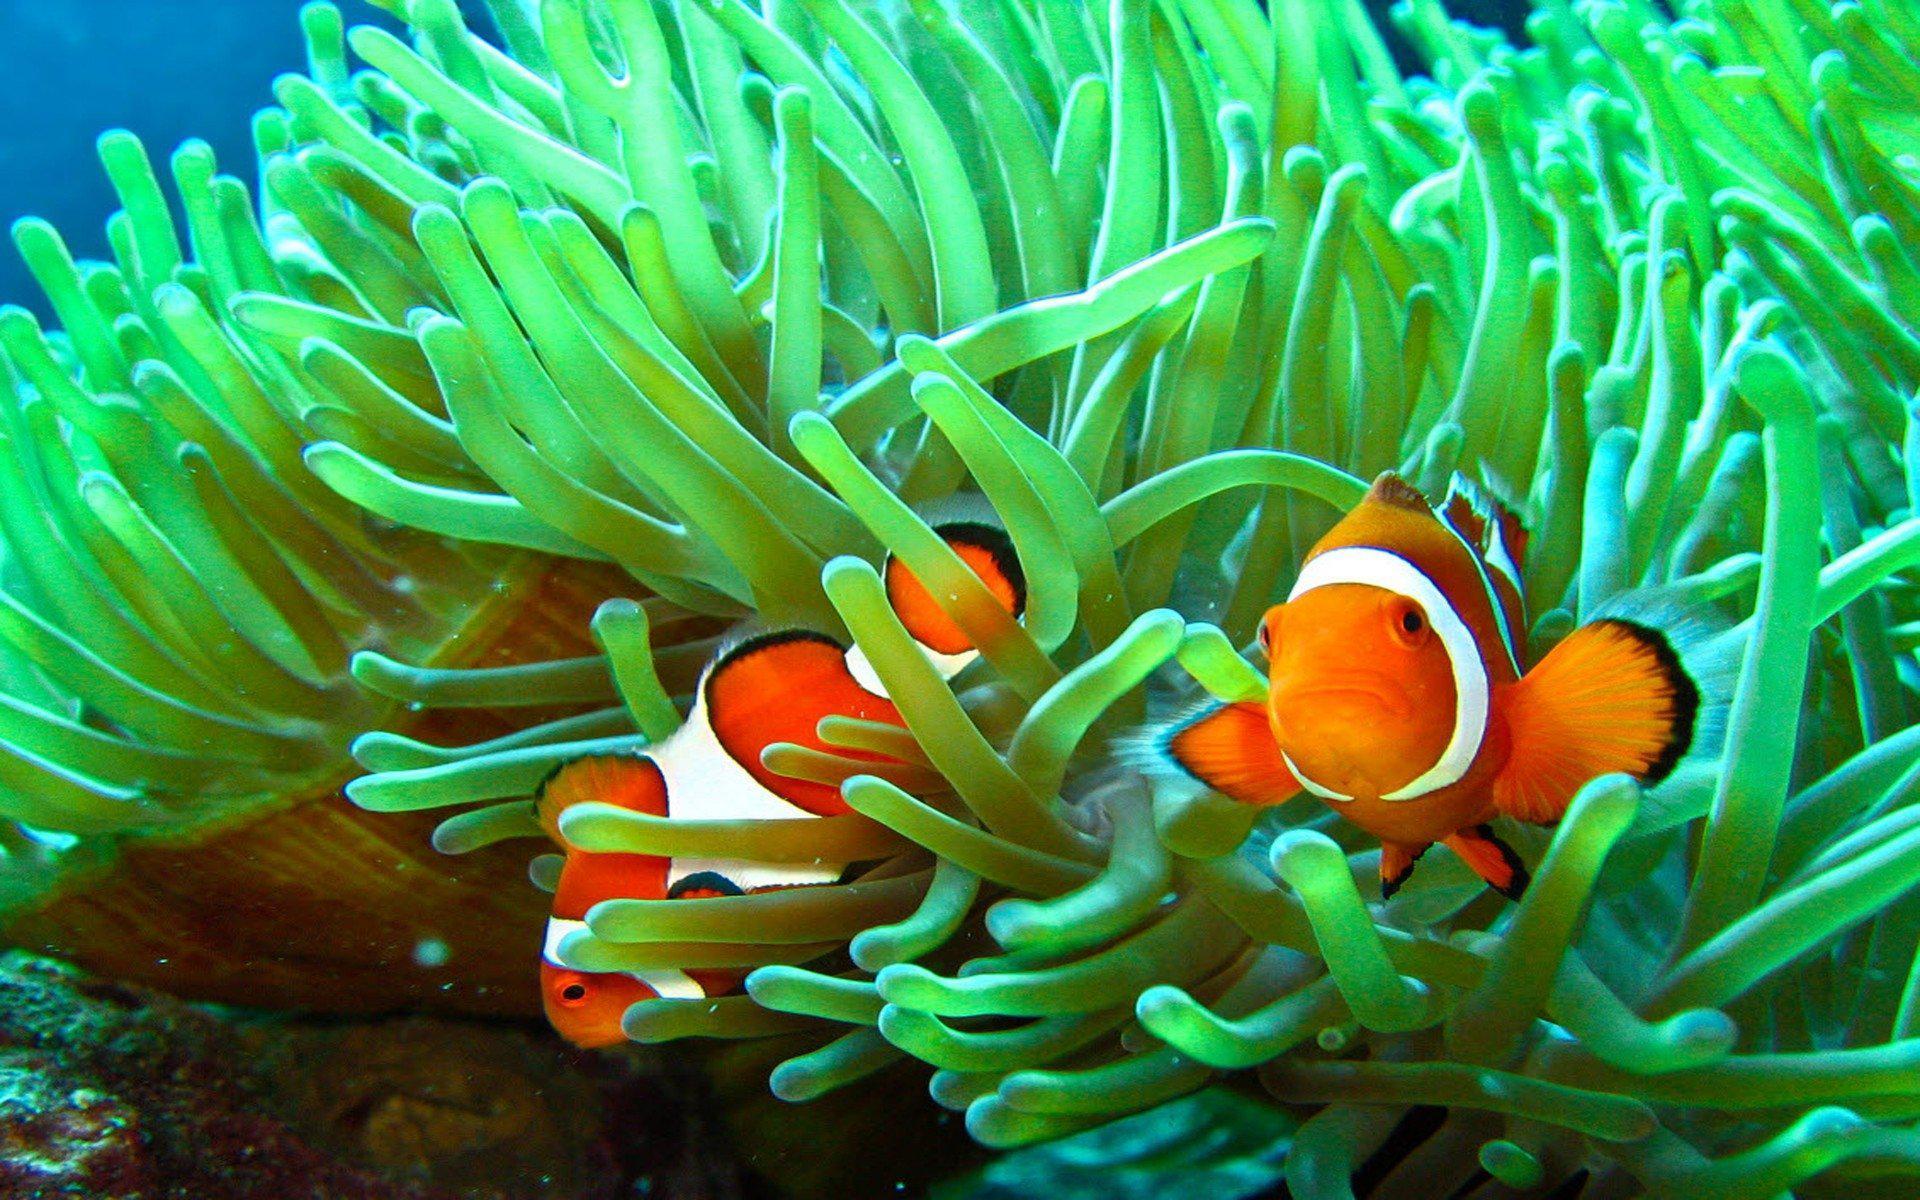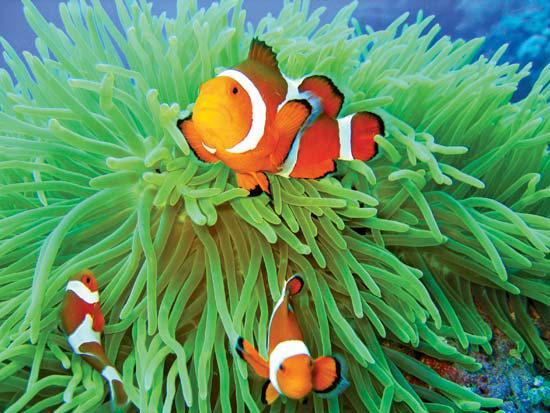The first image is the image on the left, the second image is the image on the right. Examine the images to the left and right. Is the description "In both images the fish are near the sea anemone" accurate? Answer yes or no. Yes. 